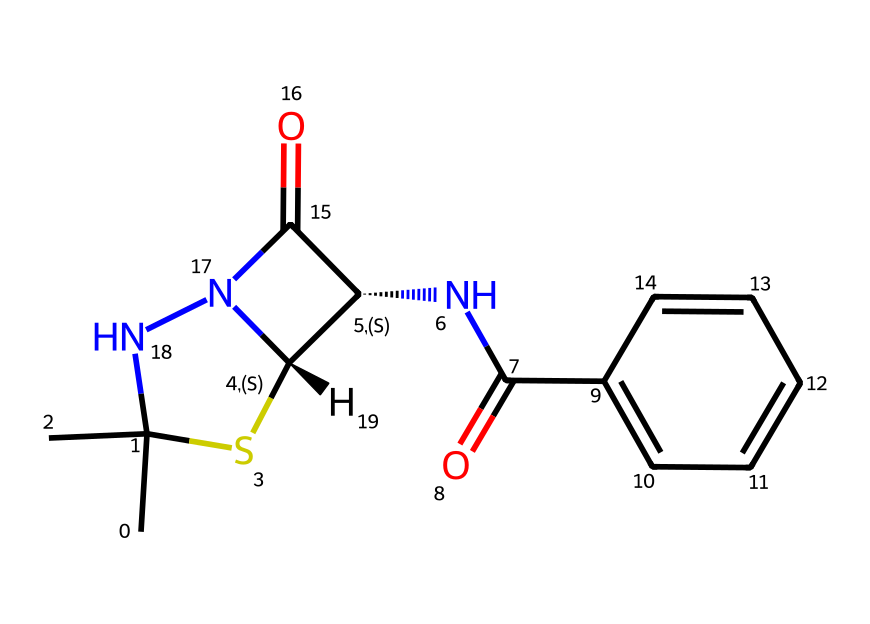What is the name of this chemical? The SMILES representation provided corresponds to Penicillin. This name relates to its structure, which includes specific functional groups characteristic of penicillins such as the beta-lactam ring.
Answer: Penicillin How many nitrogen atoms are in this structure? By analyzing the SMILES notation, we can identify two nitrogen atoms present. One appears in the amide (C(=O)N) and one is the part of the thiazolidine ring.
Answer: two What type of functional group is connected to the benzene ring? The structure includes an amide functional group (C(=O)N) connected directly to the benzene ring, which is derived from the incorporation of the nitrogen into the carbonyl group.
Answer: amide What is the stereochemistry at C2 in the thiazolidine ring? The stereochemistry at C2 is specified by the 'C@' notation in the SMILES. This indicates that it has a specific chirality, being a chiral center with a distinct configuration for this part of the molecule.
Answer: chiral What is the primary ring structure noted in this chemical? The primary ring structure in this chemical is the beta-lactam ring, which is essential to its antibiotic properties. The presence of the carbonyl and nitrogen atom contributes to this classification.
Answer: beta-lactam How many rings are present in the overall structure? There are two rings present in this structure: one is the thiazolidine ring and the other is the beta-lactam ring, which is critical to the activity of penicillin as an antibiotic.
Answer: two 